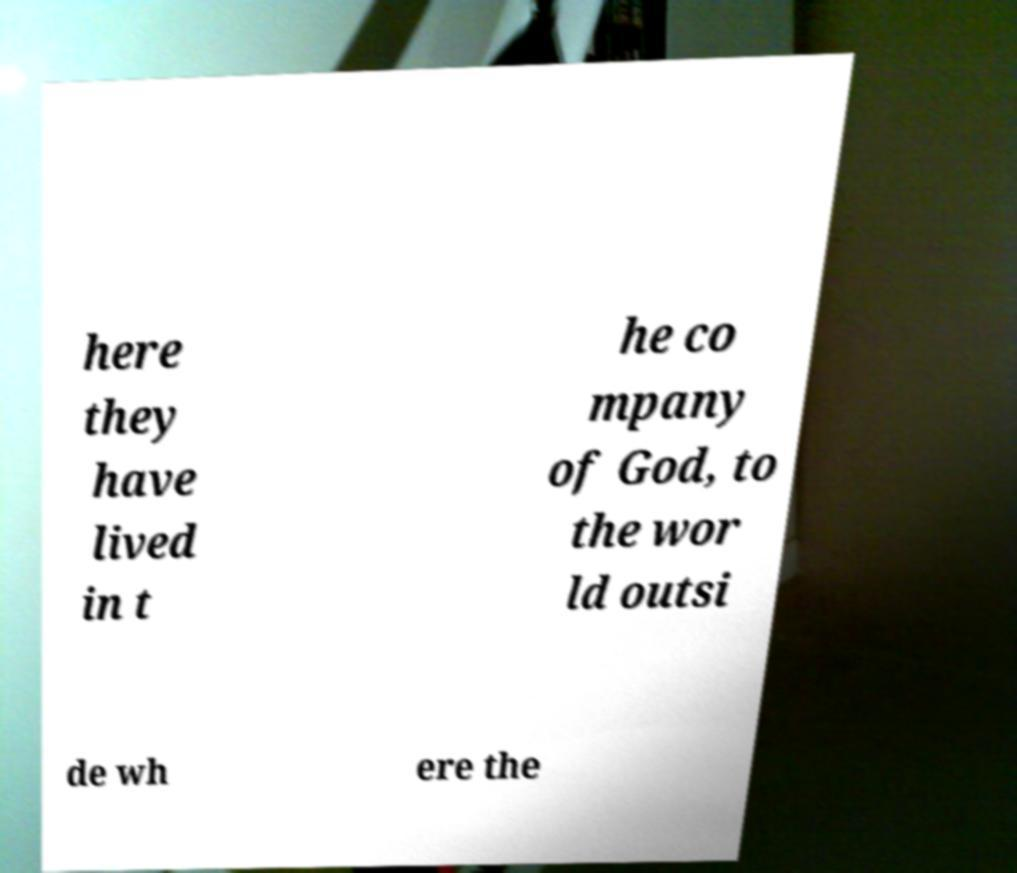Could you assist in decoding the text presented in this image and type it out clearly? here they have lived in t he co mpany of God, to the wor ld outsi de wh ere the 